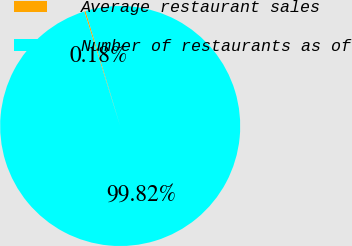<chart> <loc_0><loc_0><loc_500><loc_500><pie_chart><fcel>Average restaurant sales<fcel>Number of restaurants as of<nl><fcel>0.18%<fcel>99.82%<nl></chart> 